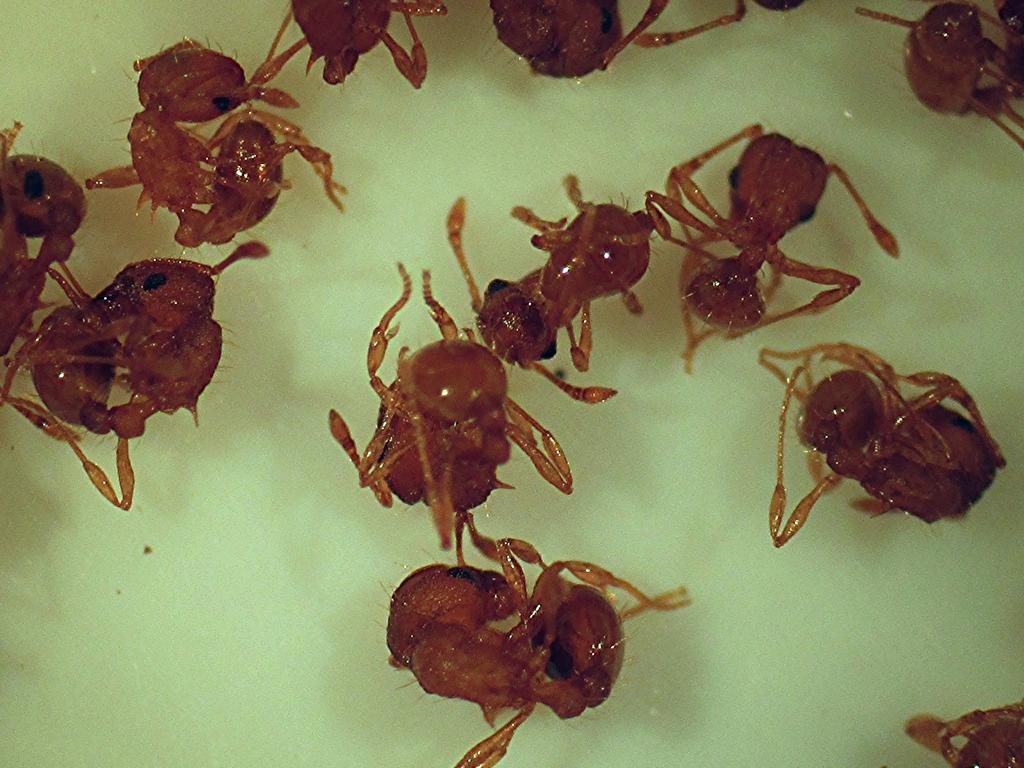How would you summarize this image in a sentence or two? There are few ants which are in red color are in water. 